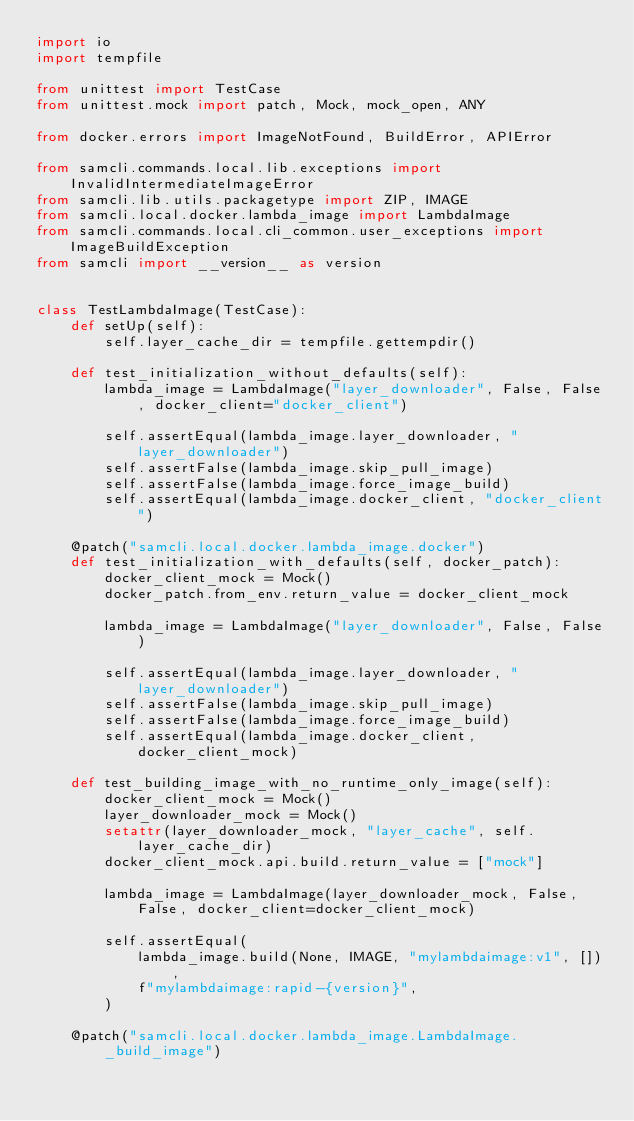<code> <loc_0><loc_0><loc_500><loc_500><_Python_>import io
import tempfile

from unittest import TestCase
from unittest.mock import patch, Mock, mock_open, ANY

from docker.errors import ImageNotFound, BuildError, APIError

from samcli.commands.local.lib.exceptions import InvalidIntermediateImageError
from samcli.lib.utils.packagetype import ZIP, IMAGE
from samcli.local.docker.lambda_image import LambdaImage
from samcli.commands.local.cli_common.user_exceptions import ImageBuildException
from samcli import __version__ as version


class TestLambdaImage(TestCase):
    def setUp(self):
        self.layer_cache_dir = tempfile.gettempdir()

    def test_initialization_without_defaults(self):
        lambda_image = LambdaImage("layer_downloader", False, False, docker_client="docker_client")

        self.assertEqual(lambda_image.layer_downloader, "layer_downloader")
        self.assertFalse(lambda_image.skip_pull_image)
        self.assertFalse(lambda_image.force_image_build)
        self.assertEqual(lambda_image.docker_client, "docker_client")

    @patch("samcli.local.docker.lambda_image.docker")
    def test_initialization_with_defaults(self, docker_patch):
        docker_client_mock = Mock()
        docker_patch.from_env.return_value = docker_client_mock

        lambda_image = LambdaImage("layer_downloader", False, False)

        self.assertEqual(lambda_image.layer_downloader, "layer_downloader")
        self.assertFalse(lambda_image.skip_pull_image)
        self.assertFalse(lambda_image.force_image_build)
        self.assertEqual(lambda_image.docker_client, docker_client_mock)

    def test_building_image_with_no_runtime_only_image(self):
        docker_client_mock = Mock()
        layer_downloader_mock = Mock()
        setattr(layer_downloader_mock, "layer_cache", self.layer_cache_dir)
        docker_client_mock.api.build.return_value = ["mock"]

        lambda_image = LambdaImage(layer_downloader_mock, False, False, docker_client=docker_client_mock)

        self.assertEqual(
            lambda_image.build(None, IMAGE, "mylambdaimage:v1", []),
            f"mylambdaimage:rapid-{version}",
        )

    @patch("samcli.local.docker.lambda_image.LambdaImage._build_image")</code> 